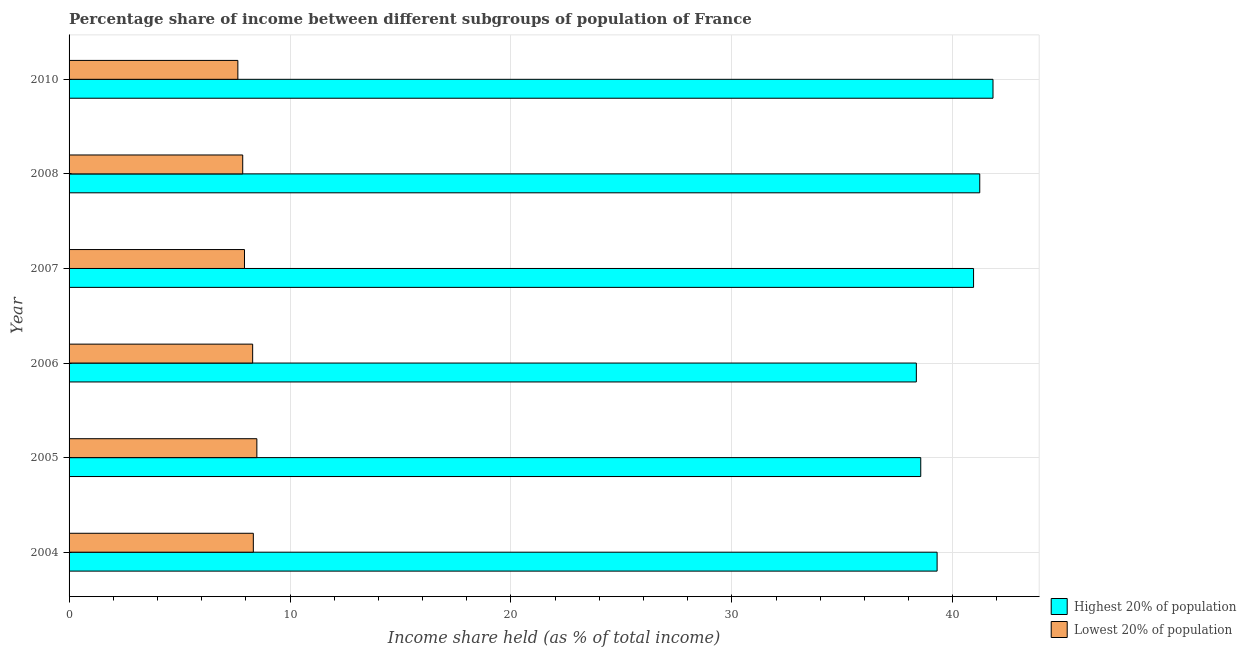Are the number of bars on each tick of the Y-axis equal?
Your answer should be compact. Yes. How many bars are there on the 5th tick from the top?
Your answer should be compact. 2. What is the income share held by highest 20% of the population in 2006?
Your answer should be very brief. 38.35. Across all years, what is the maximum income share held by lowest 20% of the population?
Offer a terse response. 8.5. Across all years, what is the minimum income share held by lowest 20% of the population?
Offer a very short reply. 7.64. In which year was the income share held by highest 20% of the population minimum?
Your answer should be very brief. 2006. What is the total income share held by lowest 20% of the population in the graph?
Make the answer very short. 48.59. What is the difference between the income share held by highest 20% of the population in 2007 and that in 2010?
Give a very brief answer. -0.88. What is the difference between the income share held by highest 20% of the population in 2006 and the income share held by lowest 20% of the population in 2008?
Offer a terse response. 30.49. What is the average income share held by lowest 20% of the population per year?
Provide a succinct answer. 8.1. What is the ratio of the income share held by highest 20% of the population in 2005 to that in 2007?
Provide a short and direct response. 0.94. Is the income share held by lowest 20% of the population in 2005 less than that in 2006?
Provide a short and direct response. No. Is the difference between the income share held by lowest 20% of the population in 2004 and 2007 greater than the difference between the income share held by highest 20% of the population in 2004 and 2007?
Provide a short and direct response. Yes. What is the difference between the highest and the lowest income share held by lowest 20% of the population?
Give a very brief answer. 0.86. What does the 1st bar from the top in 2004 represents?
Offer a very short reply. Lowest 20% of population. What does the 2nd bar from the bottom in 2006 represents?
Your answer should be very brief. Lowest 20% of population. What is the title of the graph?
Offer a very short reply. Percentage share of income between different subgroups of population of France. Does "Under five" appear as one of the legend labels in the graph?
Provide a short and direct response. No. What is the label or title of the X-axis?
Provide a succinct answer. Income share held (as % of total income). What is the label or title of the Y-axis?
Your answer should be compact. Year. What is the Income share held (as % of total income) of Highest 20% of population in 2004?
Ensure brevity in your answer.  39.29. What is the Income share held (as % of total income) of Lowest 20% of population in 2004?
Offer a terse response. 8.34. What is the Income share held (as % of total income) in Highest 20% of population in 2005?
Keep it short and to the point. 38.55. What is the Income share held (as % of total income) of Highest 20% of population in 2006?
Your response must be concise. 38.35. What is the Income share held (as % of total income) of Lowest 20% of population in 2006?
Keep it short and to the point. 8.31. What is the Income share held (as % of total income) of Highest 20% of population in 2007?
Your answer should be compact. 40.94. What is the Income share held (as % of total income) of Lowest 20% of population in 2007?
Offer a very short reply. 7.94. What is the Income share held (as % of total income) in Highest 20% of population in 2008?
Your answer should be compact. 41.22. What is the Income share held (as % of total income) in Lowest 20% of population in 2008?
Your answer should be compact. 7.86. What is the Income share held (as % of total income) of Highest 20% of population in 2010?
Give a very brief answer. 41.82. What is the Income share held (as % of total income) in Lowest 20% of population in 2010?
Offer a terse response. 7.64. Across all years, what is the maximum Income share held (as % of total income) of Highest 20% of population?
Provide a succinct answer. 41.82. Across all years, what is the minimum Income share held (as % of total income) of Highest 20% of population?
Ensure brevity in your answer.  38.35. Across all years, what is the minimum Income share held (as % of total income) of Lowest 20% of population?
Keep it short and to the point. 7.64. What is the total Income share held (as % of total income) of Highest 20% of population in the graph?
Give a very brief answer. 240.17. What is the total Income share held (as % of total income) in Lowest 20% of population in the graph?
Offer a very short reply. 48.59. What is the difference between the Income share held (as % of total income) of Highest 20% of population in 2004 and that in 2005?
Make the answer very short. 0.74. What is the difference between the Income share held (as % of total income) of Lowest 20% of population in 2004 and that in 2005?
Offer a terse response. -0.16. What is the difference between the Income share held (as % of total income) of Lowest 20% of population in 2004 and that in 2006?
Your response must be concise. 0.03. What is the difference between the Income share held (as % of total income) in Highest 20% of population in 2004 and that in 2007?
Make the answer very short. -1.65. What is the difference between the Income share held (as % of total income) in Highest 20% of population in 2004 and that in 2008?
Provide a short and direct response. -1.93. What is the difference between the Income share held (as % of total income) of Lowest 20% of population in 2004 and that in 2008?
Provide a succinct answer. 0.48. What is the difference between the Income share held (as % of total income) in Highest 20% of population in 2004 and that in 2010?
Offer a very short reply. -2.53. What is the difference between the Income share held (as % of total income) of Lowest 20% of population in 2004 and that in 2010?
Your answer should be compact. 0.7. What is the difference between the Income share held (as % of total income) in Highest 20% of population in 2005 and that in 2006?
Offer a very short reply. 0.2. What is the difference between the Income share held (as % of total income) in Lowest 20% of population in 2005 and that in 2006?
Your answer should be very brief. 0.19. What is the difference between the Income share held (as % of total income) of Highest 20% of population in 2005 and that in 2007?
Ensure brevity in your answer.  -2.39. What is the difference between the Income share held (as % of total income) in Lowest 20% of population in 2005 and that in 2007?
Give a very brief answer. 0.56. What is the difference between the Income share held (as % of total income) in Highest 20% of population in 2005 and that in 2008?
Provide a short and direct response. -2.67. What is the difference between the Income share held (as % of total income) in Lowest 20% of population in 2005 and that in 2008?
Offer a terse response. 0.64. What is the difference between the Income share held (as % of total income) in Highest 20% of population in 2005 and that in 2010?
Give a very brief answer. -3.27. What is the difference between the Income share held (as % of total income) of Lowest 20% of population in 2005 and that in 2010?
Provide a succinct answer. 0.86. What is the difference between the Income share held (as % of total income) of Highest 20% of population in 2006 and that in 2007?
Ensure brevity in your answer.  -2.59. What is the difference between the Income share held (as % of total income) in Lowest 20% of population in 2006 and that in 2007?
Keep it short and to the point. 0.37. What is the difference between the Income share held (as % of total income) of Highest 20% of population in 2006 and that in 2008?
Your response must be concise. -2.87. What is the difference between the Income share held (as % of total income) in Lowest 20% of population in 2006 and that in 2008?
Provide a short and direct response. 0.45. What is the difference between the Income share held (as % of total income) of Highest 20% of population in 2006 and that in 2010?
Provide a succinct answer. -3.47. What is the difference between the Income share held (as % of total income) in Lowest 20% of population in 2006 and that in 2010?
Offer a very short reply. 0.67. What is the difference between the Income share held (as % of total income) of Highest 20% of population in 2007 and that in 2008?
Your response must be concise. -0.28. What is the difference between the Income share held (as % of total income) in Highest 20% of population in 2007 and that in 2010?
Give a very brief answer. -0.88. What is the difference between the Income share held (as % of total income) in Lowest 20% of population in 2008 and that in 2010?
Offer a very short reply. 0.22. What is the difference between the Income share held (as % of total income) of Highest 20% of population in 2004 and the Income share held (as % of total income) of Lowest 20% of population in 2005?
Make the answer very short. 30.79. What is the difference between the Income share held (as % of total income) in Highest 20% of population in 2004 and the Income share held (as % of total income) in Lowest 20% of population in 2006?
Your answer should be compact. 30.98. What is the difference between the Income share held (as % of total income) of Highest 20% of population in 2004 and the Income share held (as % of total income) of Lowest 20% of population in 2007?
Offer a very short reply. 31.35. What is the difference between the Income share held (as % of total income) of Highest 20% of population in 2004 and the Income share held (as % of total income) of Lowest 20% of population in 2008?
Your response must be concise. 31.43. What is the difference between the Income share held (as % of total income) of Highest 20% of population in 2004 and the Income share held (as % of total income) of Lowest 20% of population in 2010?
Keep it short and to the point. 31.65. What is the difference between the Income share held (as % of total income) in Highest 20% of population in 2005 and the Income share held (as % of total income) in Lowest 20% of population in 2006?
Your answer should be compact. 30.24. What is the difference between the Income share held (as % of total income) of Highest 20% of population in 2005 and the Income share held (as % of total income) of Lowest 20% of population in 2007?
Your answer should be very brief. 30.61. What is the difference between the Income share held (as % of total income) of Highest 20% of population in 2005 and the Income share held (as % of total income) of Lowest 20% of population in 2008?
Provide a succinct answer. 30.69. What is the difference between the Income share held (as % of total income) in Highest 20% of population in 2005 and the Income share held (as % of total income) in Lowest 20% of population in 2010?
Make the answer very short. 30.91. What is the difference between the Income share held (as % of total income) of Highest 20% of population in 2006 and the Income share held (as % of total income) of Lowest 20% of population in 2007?
Give a very brief answer. 30.41. What is the difference between the Income share held (as % of total income) of Highest 20% of population in 2006 and the Income share held (as % of total income) of Lowest 20% of population in 2008?
Offer a very short reply. 30.49. What is the difference between the Income share held (as % of total income) of Highest 20% of population in 2006 and the Income share held (as % of total income) of Lowest 20% of population in 2010?
Your answer should be very brief. 30.71. What is the difference between the Income share held (as % of total income) in Highest 20% of population in 2007 and the Income share held (as % of total income) in Lowest 20% of population in 2008?
Offer a terse response. 33.08. What is the difference between the Income share held (as % of total income) in Highest 20% of population in 2007 and the Income share held (as % of total income) in Lowest 20% of population in 2010?
Your answer should be very brief. 33.3. What is the difference between the Income share held (as % of total income) of Highest 20% of population in 2008 and the Income share held (as % of total income) of Lowest 20% of population in 2010?
Offer a very short reply. 33.58. What is the average Income share held (as % of total income) of Highest 20% of population per year?
Provide a short and direct response. 40.03. What is the average Income share held (as % of total income) of Lowest 20% of population per year?
Offer a very short reply. 8.1. In the year 2004, what is the difference between the Income share held (as % of total income) of Highest 20% of population and Income share held (as % of total income) of Lowest 20% of population?
Give a very brief answer. 30.95. In the year 2005, what is the difference between the Income share held (as % of total income) of Highest 20% of population and Income share held (as % of total income) of Lowest 20% of population?
Your answer should be compact. 30.05. In the year 2006, what is the difference between the Income share held (as % of total income) in Highest 20% of population and Income share held (as % of total income) in Lowest 20% of population?
Offer a terse response. 30.04. In the year 2008, what is the difference between the Income share held (as % of total income) of Highest 20% of population and Income share held (as % of total income) of Lowest 20% of population?
Your response must be concise. 33.36. In the year 2010, what is the difference between the Income share held (as % of total income) in Highest 20% of population and Income share held (as % of total income) in Lowest 20% of population?
Ensure brevity in your answer.  34.18. What is the ratio of the Income share held (as % of total income) in Highest 20% of population in 2004 to that in 2005?
Provide a succinct answer. 1.02. What is the ratio of the Income share held (as % of total income) in Lowest 20% of population in 2004 to that in 2005?
Give a very brief answer. 0.98. What is the ratio of the Income share held (as % of total income) of Highest 20% of population in 2004 to that in 2006?
Make the answer very short. 1.02. What is the ratio of the Income share held (as % of total income) of Lowest 20% of population in 2004 to that in 2006?
Offer a terse response. 1. What is the ratio of the Income share held (as % of total income) of Highest 20% of population in 2004 to that in 2007?
Your response must be concise. 0.96. What is the ratio of the Income share held (as % of total income) of Lowest 20% of population in 2004 to that in 2007?
Your response must be concise. 1.05. What is the ratio of the Income share held (as % of total income) in Highest 20% of population in 2004 to that in 2008?
Ensure brevity in your answer.  0.95. What is the ratio of the Income share held (as % of total income) in Lowest 20% of population in 2004 to that in 2008?
Your answer should be very brief. 1.06. What is the ratio of the Income share held (as % of total income) of Highest 20% of population in 2004 to that in 2010?
Provide a short and direct response. 0.94. What is the ratio of the Income share held (as % of total income) of Lowest 20% of population in 2004 to that in 2010?
Your response must be concise. 1.09. What is the ratio of the Income share held (as % of total income) in Lowest 20% of population in 2005 to that in 2006?
Offer a very short reply. 1.02. What is the ratio of the Income share held (as % of total income) in Highest 20% of population in 2005 to that in 2007?
Keep it short and to the point. 0.94. What is the ratio of the Income share held (as % of total income) of Lowest 20% of population in 2005 to that in 2007?
Offer a very short reply. 1.07. What is the ratio of the Income share held (as % of total income) in Highest 20% of population in 2005 to that in 2008?
Your answer should be very brief. 0.94. What is the ratio of the Income share held (as % of total income) of Lowest 20% of population in 2005 to that in 2008?
Keep it short and to the point. 1.08. What is the ratio of the Income share held (as % of total income) in Highest 20% of population in 2005 to that in 2010?
Keep it short and to the point. 0.92. What is the ratio of the Income share held (as % of total income) in Lowest 20% of population in 2005 to that in 2010?
Provide a succinct answer. 1.11. What is the ratio of the Income share held (as % of total income) in Highest 20% of population in 2006 to that in 2007?
Your answer should be very brief. 0.94. What is the ratio of the Income share held (as % of total income) of Lowest 20% of population in 2006 to that in 2007?
Give a very brief answer. 1.05. What is the ratio of the Income share held (as % of total income) in Highest 20% of population in 2006 to that in 2008?
Provide a short and direct response. 0.93. What is the ratio of the Income share held (as % of total income) in Lowest 20% of population in 2006 to that in 2008?
Ensure brevity in your answer.  1.06. What is the ratio of the Income share held (as % of total income) in Highest 20% of population in 2006 to that in 2010?
Your answer should be very brief. 0.92. What is the ratio of the Income share held (as % of total income) in Lowest 20% of population in 2006 to that in 2010?
Make the answer very short. 1.09. What is the ratio of the Income share held (as % of total income) of Highest 20% of population in 2007 to that in 2008?
Your answer should be very brief. 0.99. What is the ratio of the Income share held (as % of total income) of Lowest 20% of population in 2007 to that in 2008?
Offer a terse response. 1.01. What is the ratio of the Income share held (as % of total income) in Lowest 20% of population in 2007 to that in 2010?
Give a very brief answer. 1.04. What is the ratio of the Income share held (as % of total income) in Highest 20% of population in 2008 to that in 2010?
Provide a succinct answer. 0.99. What is the ratio of the Income share held (as % of total income) of Lowest 20% of population in 2008 to that in 2010?
Your answer should be very brief. 1.03. What is the difference between the highest and the second highest Income share held (as % of total income) of Lowest 20% of population?
Offer a terse response. 0.16. What is the difference between the highest and the lowest Income share held (as % of total income) in Highest 20% of population?
Provide a short and direct response. 3.47. What is the difference between the highest and the lowest Income share held (as % of total income) in Lowest 20% of population?
Your answer should be compact. 0.86. 